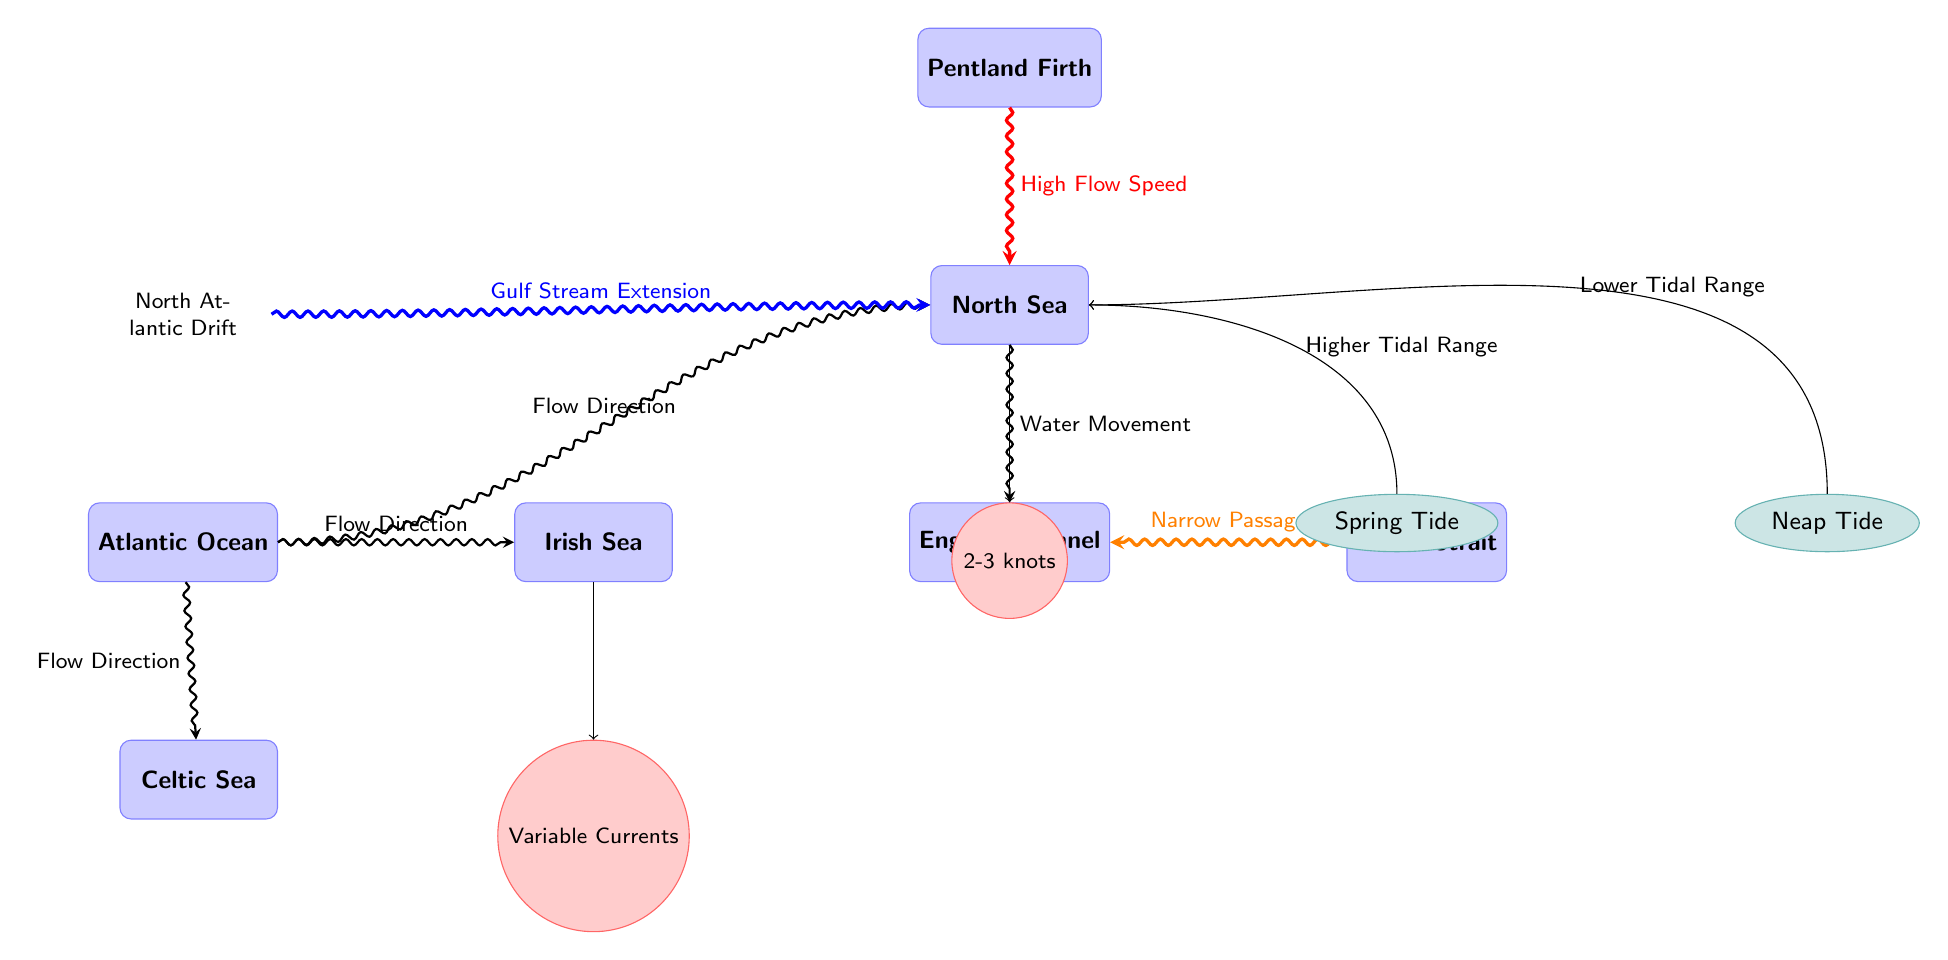What water body is located directly above the English Channel? The diagram indicates that the North Sea is the water body situated directly above the English Channel, as the flow direction arrows reinforce the relationship between these two nodes.
Answer: North Sea What is the flow direction from the Atlantic Ocean to the North Sea? The flow direction is indicated by the arrow showing the water movement from the Atlantic Ocean to the North Sea, confirming the path directed towards the North Sea.
Answer: Flow Direction What type of tide has a higher tidal range? The diagram highlights that the Spring Tide is the type with a higher tidal range, as shown by the directed arrow from Spring Tide towards the North Sea.
Answer: Spring Tide Which water body has variable currents? The Irish Sea is characterized by variable currents, as specified in the node indicating its flow speed, demonstrating that the currents in this area are not constant.
Answer: Variable Currents Where does the North Atlantic Drift flow towards? The North Atlantic Drift is directed towards the North Sea, as evidenced by the arrow connecting it to the North Sea node, emphasizing its role in the water dynamics of that area.
Answer: North Sea What is the approximate flow speed in the North Sea? The node under the North Sea specifically states that the flow speed is between 2-3 knots, representing the velocity of currents in this region.
Answer: 2-3 knots Which passage is indicated as a narrow passage in the diagram? The Dover Strait is depicted as the narrow passage in the diagram, as shown by the arrow signaling its connection to the English Channel and highlighting its geographical significance.
Answer: Dover Strait What does the arrow from Neap Tide indicate? The arrow from Neap Tide indicates a lower tidal range, which is explicitly stated in the diagram, confirming the effect of this type of tide on the tidal dynamics within the North Sea.
Answer: Lower Tidal Range What body of water is located below the North Sea? The English Channel is the water body situated directly below the North Sea, as presented by the relative positioning of the nodes.
Answer: English Channel What is indicated as a feature of the Pentland Firth in the diagram? The diagram notes that there is high flow speed from the Pentland Firth to the North Sea, illustrating the significant current dynamics in that area.
Answer: High Flow Speed 